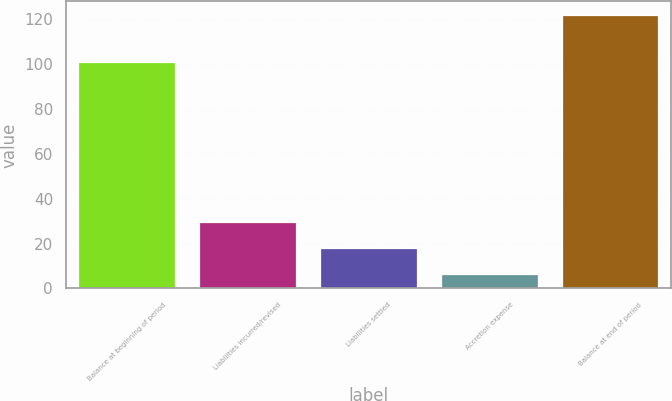<chart> <loc_0><loc_0><loc_500><loc_500><bar_chart><fcel>Balance at beginning of period<fcel>Liabilities incurred/revised<fcel>Liabilities settled<fcel>Accretion expense<fcel>Balance at end of period<nl><fcel>100.9<fcel>29.6<fcel>18.05<fcel>6.5<fcel>122<nl></chart> 